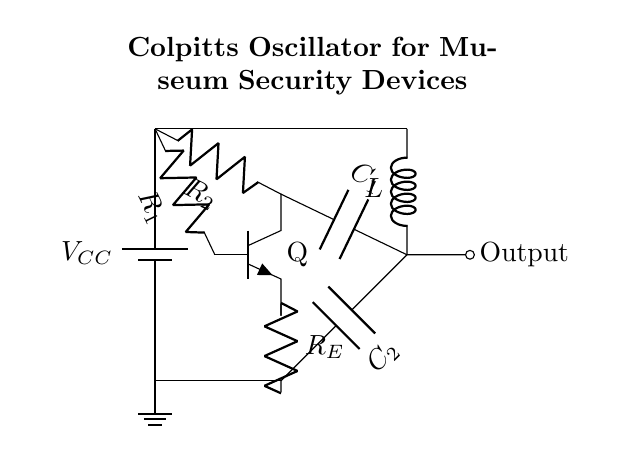What type of oscillator is this circuit? This circuit is identified as a Colpitts oscillator, which is characterized by the use of capacitive voltage dividers in its feedback loop, evident from the presence of capacitors C1 and C2 that play crucial roles in determining the oscillation frequency.
Answer: Colpitts oscillator How many capacitors are present in this circuit? In the circuit diagram, there are two capacitors labeled as C1 and C2. Their positioning indicates they are part of the feedback network, which is essential for the oscillator's function.
Answer: Two What is the role of the inductor in this circuit? The inductor, labeled as L, works in conjunction with the capacitors to form a resonant circuit. It helps determine the oscillation frequency, working together with C1 and C2 to establish a parallel resonant circuit crucial for oscillating behavior.
Answer: Frequency determination Which component provides the output of the oscillator? The output is taken from the point where the inductor is connected to C1, indicated by the short line leading out of the circuit labeled as "Output." This indicates that the oscillating signal generated in the circuit is being sent out from this node.
Answer: Inductor What voltage supply is used in this circuit? The circuit has a voltage supply labeled as V_CC, which is depicted at the top of the circuit, providing power necessary for the operation of the transistor (Q) and, in turn, the entire oscillator circuit.
Answer: V_CC What is the purpose of the resistors in this circuit? The resistors (R1, R2, and R_E) are used for biasing the transistor (Q) and controlling the current flowing through the circuit. Their positions in the circuit help set the operating point and stability of the oscillator, crucial for ensuring consistent oscillation.
Answer: Current control What component is responsible for gain in this circuit? The gain in a Colpitts oscillator circuit primarily comes from the transistor (Q), which amplifies the signal from the feedback network formed by the capacitors and inductor, enabling sustained oscillation necessary for the system’s operation.
Answer: Transistor 